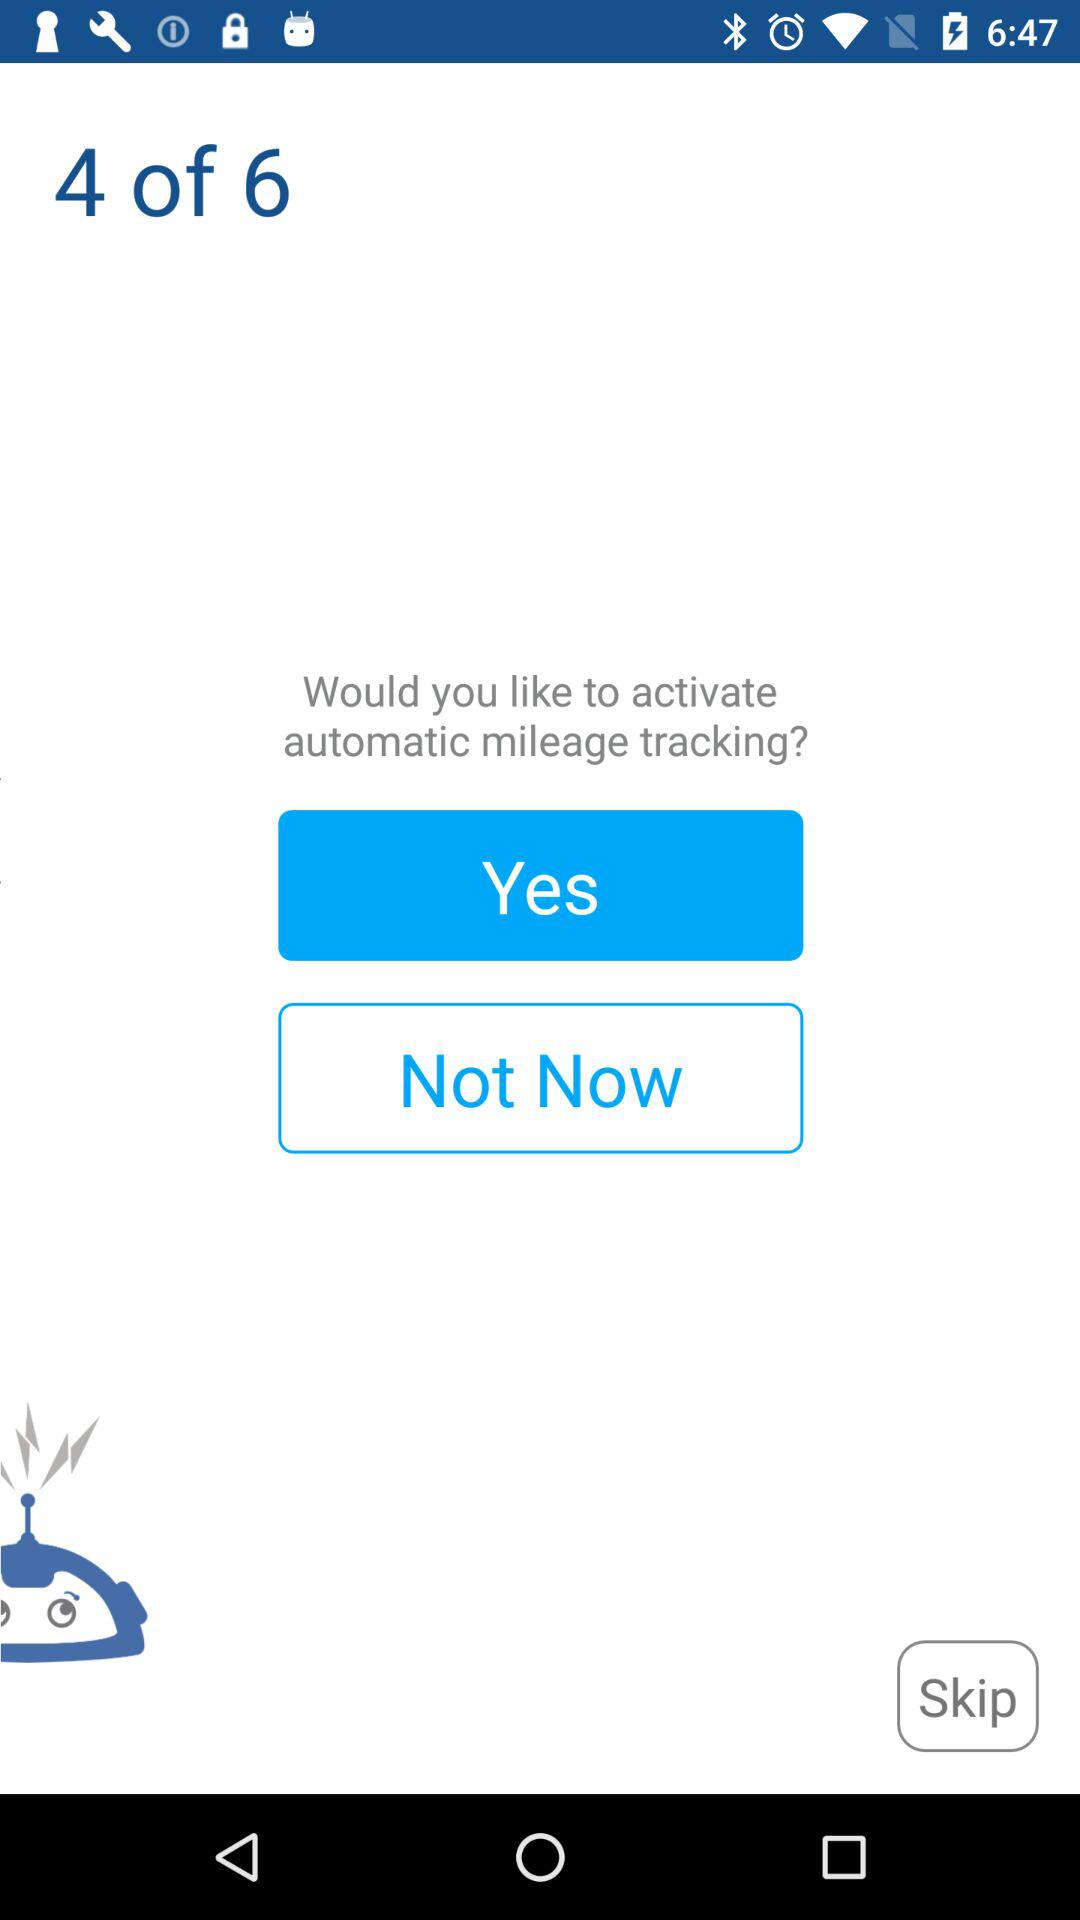What is the current page number? The current page number is 4. 